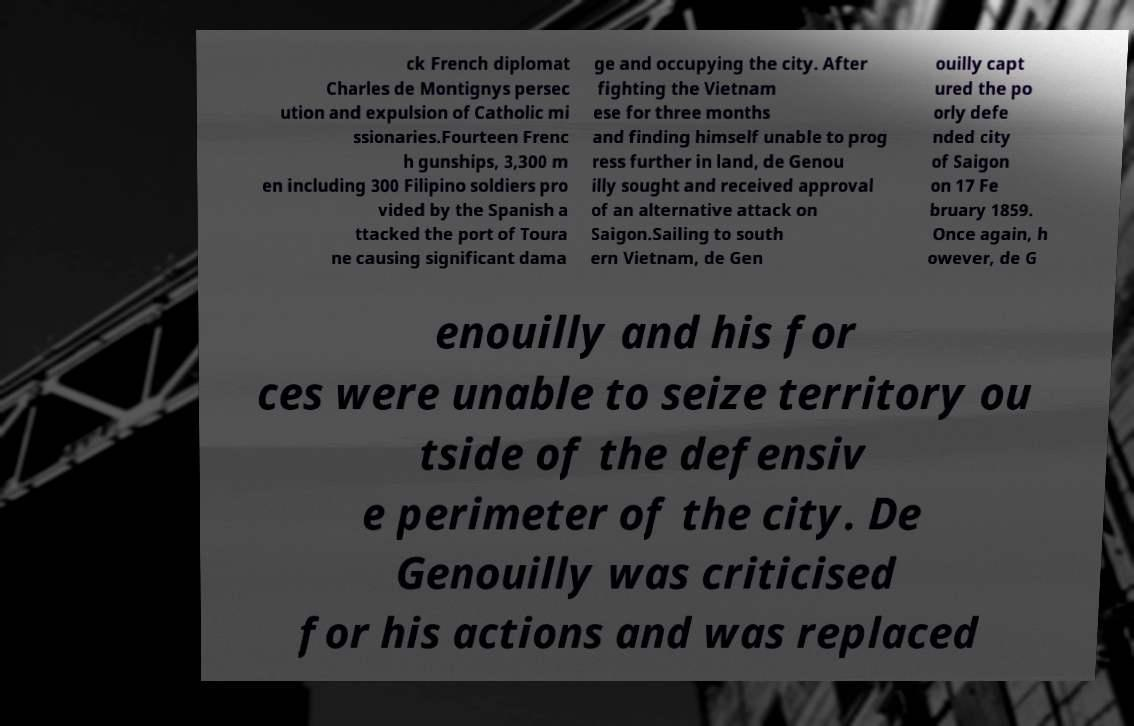Please read and relay the text visible in this image. What does it say? ck French diplomat Charles de Montignys persec ution and expulsion of Catholic mi ssionaries.Fourteen Frenc h gunships, 3,300 m en including 300 Filipino soldiers pro vided by the Spanish a ttacked the port of Toura ne causing significant dama ge and occupying the city. After fighting the Vietnam ese for three months and finding himself unable to prog ress further in land, de Genou illy sought and received approval of an alternative attack on Saigon.Sailing to south ern Vietnam, de Gen ouilly capt ured the po orly defe nded city of Saigon on 17 Fe bruary 1859. Once again, h owever, de G enouilly and his for ces were unable to seize territory ou tside of the defensiv e perimeter of the city. De Genouilly was criticised for his actions and was replaced 